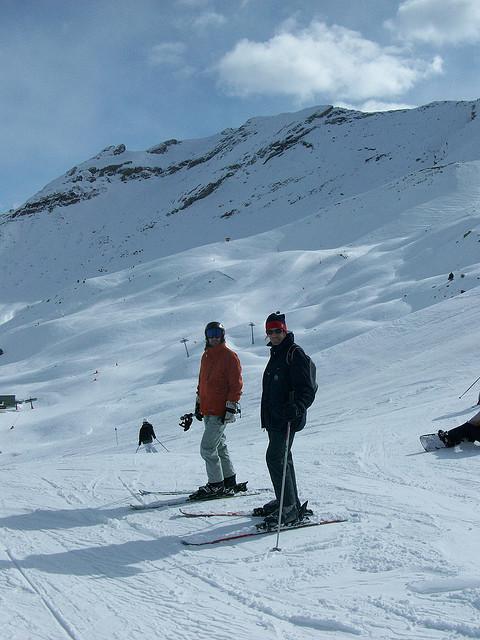Are they sitting down?
Short answer required. No. What is orange on the man?
Give a very brief answer. Jacket. What is the person doing?
Give a very brief answer. Skiing. What climate are the people in?
Be succinct. Cold. How many are wearing skis?
Write a very short answer. 3. Is the man going to spend the night in the snow?
Be succinct. No. Is this man in motion?
Concise answer only. No. How many men are there present?
Short answer required. 3. What color is the person coat?
Short answer required. Red. Is the hat black?
Quick response, please. Yes. Is this person moving or standing still?
Answer briefly. Standing still. What are the people doing?
Answer briefly. Skiing. How many people are skateboarding in this picture?
Quick response, please. 0. What mountains are these?
Be succinct. Alps. 